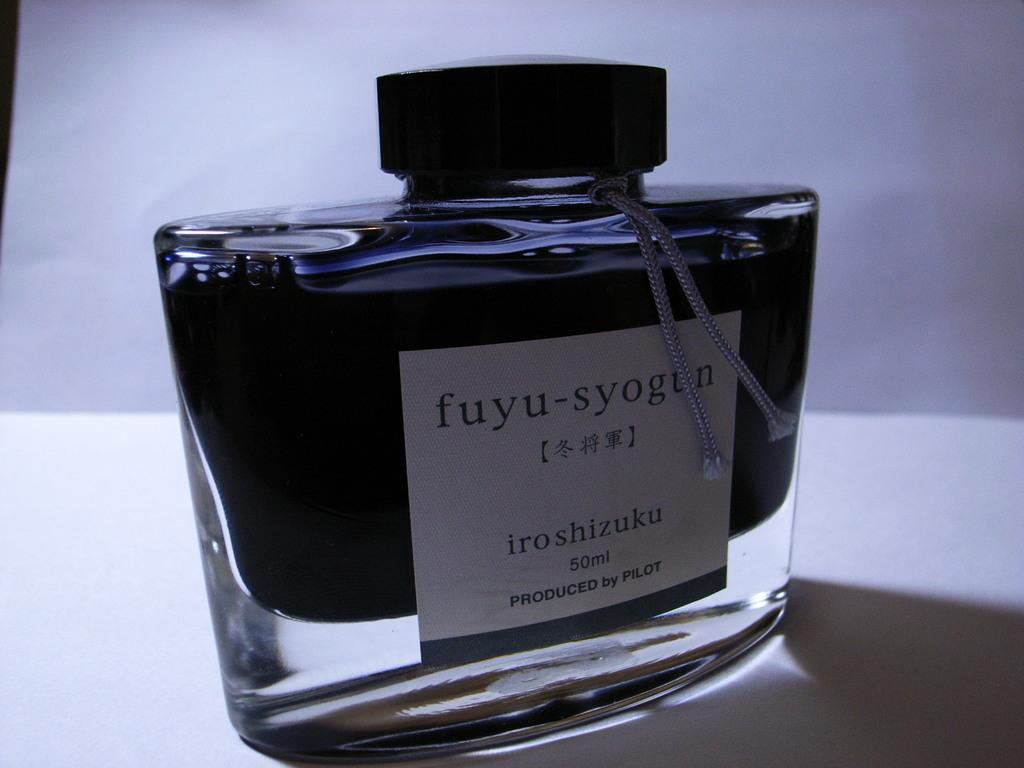<image>
Give a short and clear explanation of the subsequent image. a bottle of something with 50 ml on it 